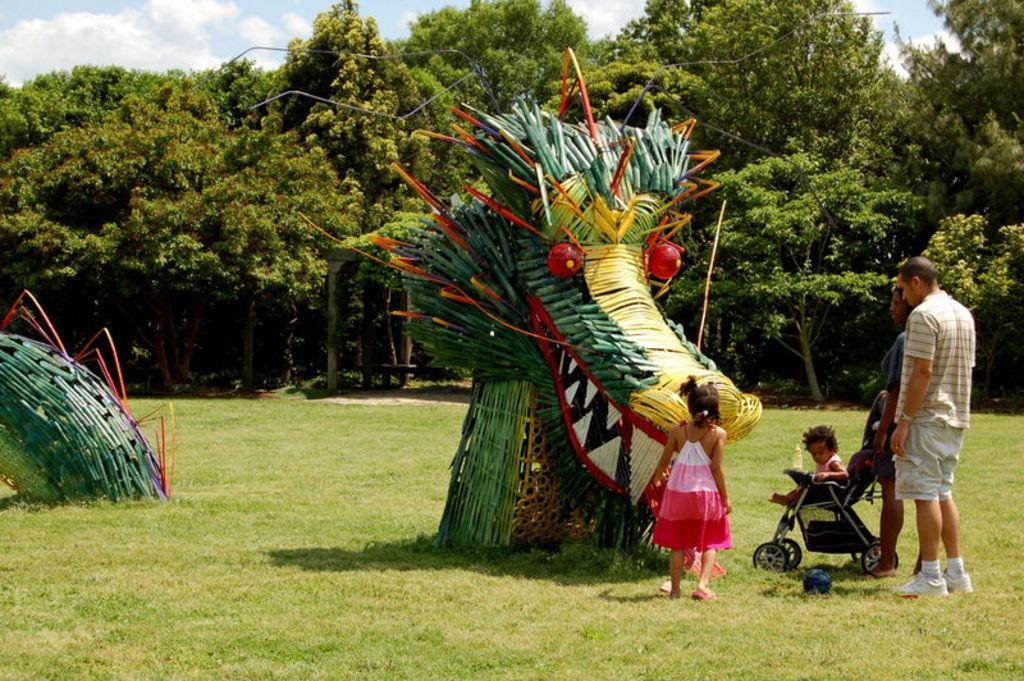How would you summarize this image in a sentence or two? This picture is clicked outside. On the right we can see the group of people standing on the ground and we can see a kid sitting in the stroller and we can see the bowl lying on the ground and we can see the objects which seems to be the carnival toys. In the background we can see the sky with the clouds and we can see the trees and the green grass. 